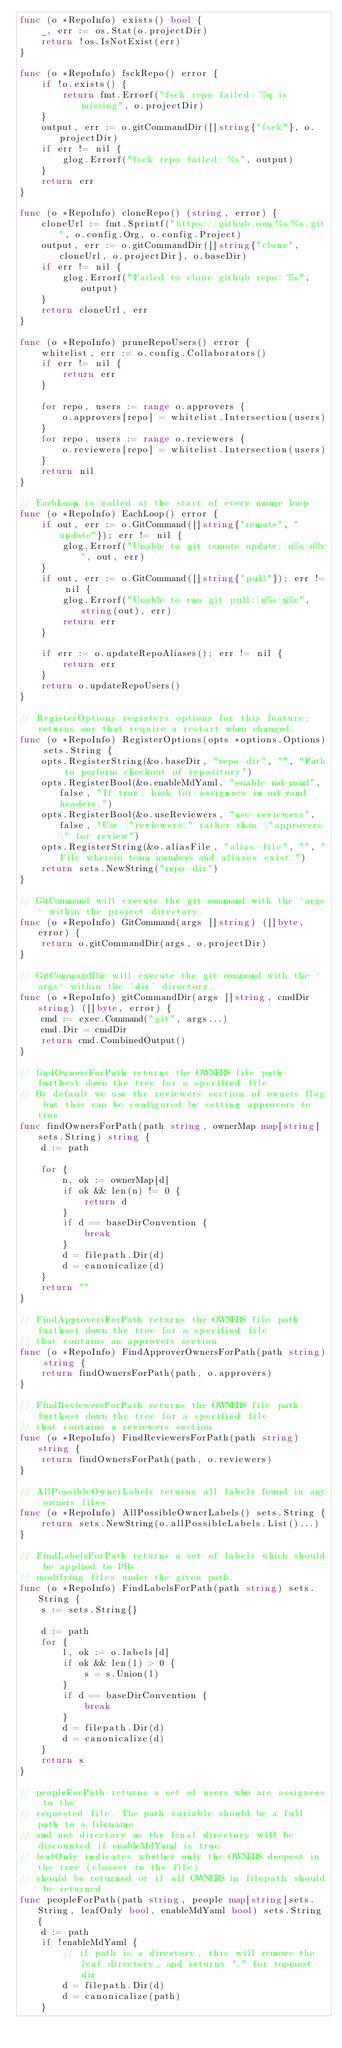Convert code to text. <code><loc_0><loc_0><loc_500><loc_500><_Go_>func (o *RepoInfo) exists() bool {
	_, err := os.Stat(o.projectDir)
	return !os.IsNotExist(err)
}

func (o *RepoInfo) fsckRepo() error {
	if !o.exists() {
		return fmt.Errorf("fsck repo failed: %q is missing", o.projectDir)
	}
	output, err := o.gitCommandDir([]string{"fsck"}, o.projectDir)
	if err != nil {
		glog.Errorf("fsck repo failed: %s", output)
	}
	return err
}

func (o *RepoInfo) cloneRepo() (string, error) {
	cloneUrl := fmt.Sprintf("https://github.com/%s/%s.git", o.config.Org, o.config.Project)
	output, err := o.gitCommandDir([]string{"clone", cloneUrl, o.projectDir}, o.baseDir)
	if err != nil {
		glog.Errorf("Failed to clone github repo: %s", output)
	}
	return cloneUrl, err
}

func (o *RepoInfo) pruneRepoUsers() error {
	whitelist, err := o.config.Collaborators()
	if err != nil {
		return err
	}

	for repo, users := range o.approvers {
		o.approvers[repo] = whitelist.Intersection(users)
	}
	for repo, users := range o.reviewers {
		o.reviewers[repo] = whitelist.Intersection(users)
	}
	return nil
}

// EachLoop is called at the start of every munge loop
func (o *RepoInfo) EachLoop() error {
	if out, err := o.GitCommand([]string{"remote", "update"}); err != nil {
		glog.Errorf("Unable to git remote update:\n%s\n%v", out, err)
	}
	if out, err := o.GitCommand([]string{"pull"}); err != nil {
		glog.Errorf("Unable to run git pull:\n%s\n%v", string(out), err)
		return err
	}

	if err := o.updateRepoAliases(); err != nil {
		return err
	}
	return o.updateRepoUsers()
}

// RegisterOptions registers options for this feature; returns any that require a restart when changed.
func (o *RepoInfo) RegisterOptions(opts *options.Options) sets.String {
	opts.RegisterString(&o.baseDir, "repo-dir", "", "Path to perform checkout of repository")
	opts.RegisterBool(&o.enableMdYaml, "enable-md-yaml", false, "If true, look for assignees in md yaml headers.")
	opts.RegisterBool(&o.useReviewers, "use-reviewers", false, "Use \"reviewers\" rather than \"approvers\" for review")
	opts.RegisterString(&o.aliasFile, "alias-file", "", "File wherein team members and aliases exist.")
	return sets.NewString("repo-dir")
}

// GitCommand will execute the git command with the `args` within the project directory.
func (o *RepoInfo) GitCommand(args []string) ([]byte, error) {
	return o.gitCommandDir(args, o.projectDir)
}

// GitCommandDir will execute the git command with the `args` within the 'dir' directory.
func (o *RepoInfo) gitCommandDir(args []string, cmdDir string) ([]byte, error) {
	cmd := exec.Command("git", args...)
	cmd.Dir = cmdDir
	return cmd.CombinedOutput()
}

// findOwnersForPath returns the OWNERS file path furthest down the tree for a specified file
// By default we use the reviewers section of owners flag but this can be configured by setting approvers to true
func findOwnersForPath(path string, ownerMap map[string]sets.String) string {
	d := path

	for {
		n, ok := ownerMap[d]
		if ok && len(n) != 0 {
			return d
		}
		if d == baseDirConvention {
			break
		}
		d = filepath.Dir(d)
		d = canonicalize(d)
	}
	return ""
}

// FindApproversForPath returns the OWNERS file path furthest down the tree for a specified file
// that contains an approvers section
func (o *RepoInfo) FindApproverOwnersForPath(path string) string {
	return findOwnersForPath(path, o.approvers)
}

// FindReviewersForPath returns the OWNERS file path furthest down the tree for a specified file
// that contains a reviewers section
func (o *RepoInfo) FindReviewersForPath(path string) string {
	return findOwnersForPath(path, o.reviewers)
}

// AllPossibleOwnerLabels returns all labels found in any owners files
func (o *RepoInfo) AllPossibleOwnerLabels() sets.String {
	return sets.NewString(o.allPossibleLabels.List()...)
}

// FindLabelsForPath returns a set of labels which should be applied to PRs
// modifying files under the given path.
func (o *RepoInfo) FindLabelsForPath(path string) sets.String {
	s := sets.String{}

	d := path
	for {
		l, ok := o.labels[d]
		if ok && len(l) > 0 {
			s = s.Union(l)
		}
		if d == baseDirConvention {
			break
		}
		d = filepath.Dir(d)
		d = canonicalize(d)
	}
	return s
}

// peopleForPath returns a set of users who are assignees to the
// requested file. The path variable should be a full path to a filename
// and not directory as the final directory will be discounted if enableMdYaml is true
// leafOnly indicates whether only the OWNERS deepest in the tree (closest to the file)
// should be returned or if all OWNERS in filepath should be returned
func peopleForPath(path string, people map[string]sets.String, leafOnly bool, enableMdYaml bool) sets.String {
	d := path
	if !enableMdYaml {
		// if path is a directory, this will remove the leaf directory, and returns "." for topmost dir
		d = filepath.Dir(d)
		d = canonicalize(path)
	}
</code> 